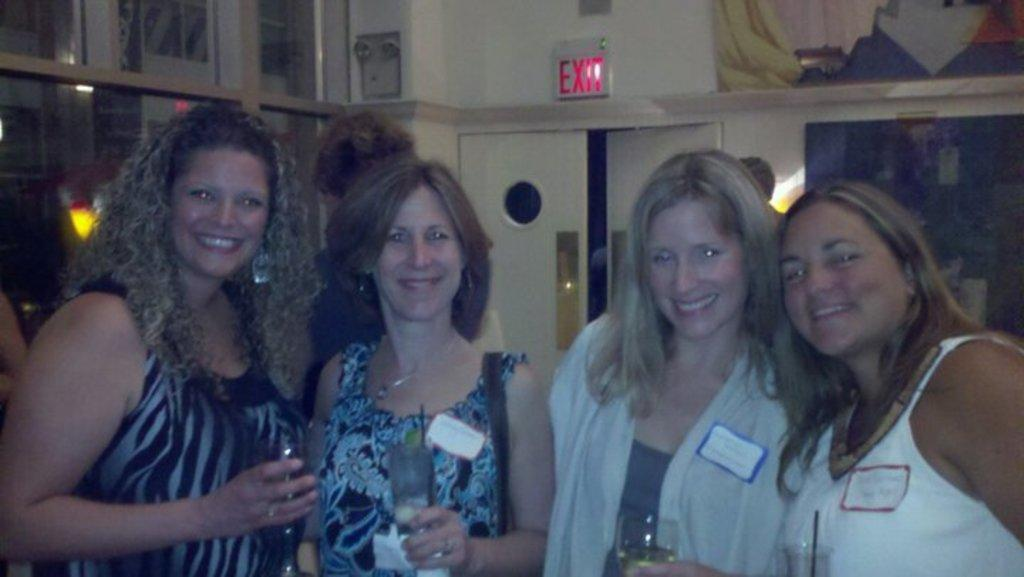How many people are in the image? There are people in the image, but the exact number is not specified. What expression do the people have in the image? The people are smiling in the image. What are the people holding in the image? The people are holding glasses in the image. What can be seen on the wall in the image? There is a wall visible in the image, but no specific details about the wall are provided. What is visible in the background of the image? There are objects and lights in the background of the image. What is the purpose of the door visible in the image? The purpose of the door is not specified, but it is visible in the image. What type of rock is being used as a coil by the monkey in the image? There is no rock, coil, or monkey present in the image. 